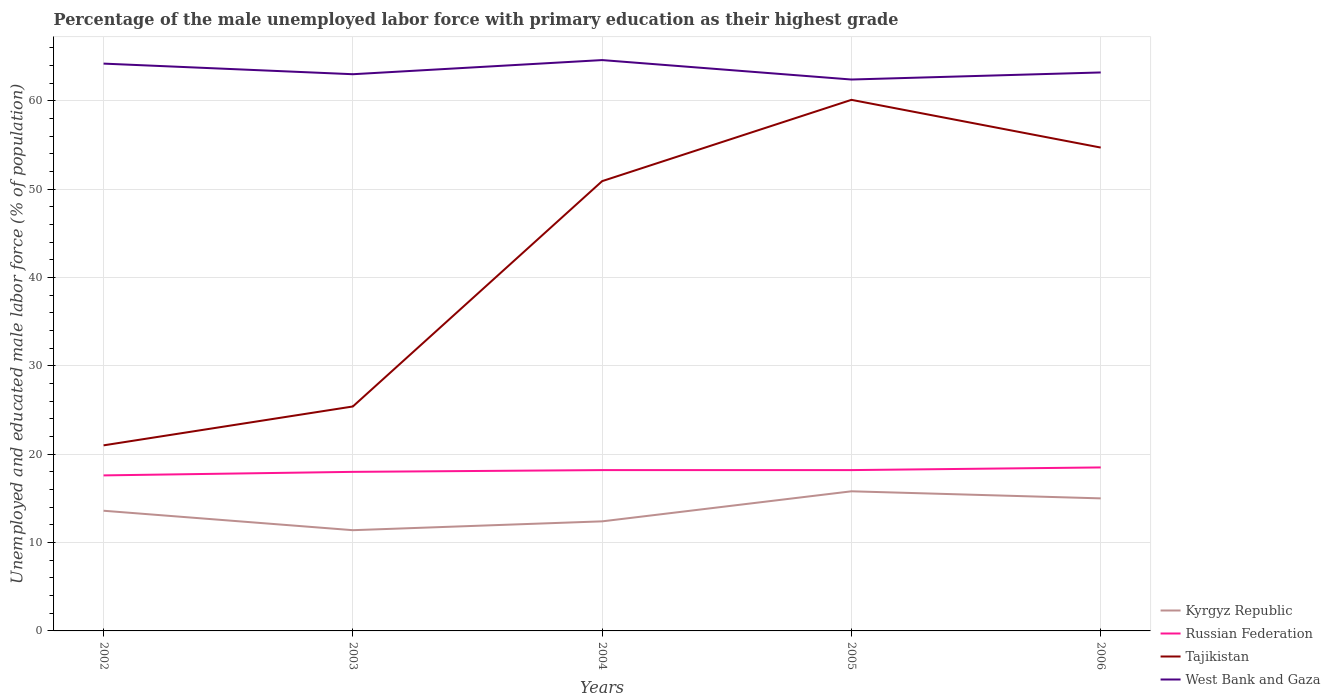How many different coloured lines are there?
Ensure brevity in your answer.  4. Across all years, what is the maximum percentage of the unemployed male labor force with primary education in Tajikistan?
Your response must be concise. 21. What is the total percentage of the unemployed male labor force with primary education in Tajikistan in the graph?
Your response must be concise. -33.7. What is the difference between the highest and the second highest percentage of the unemployed male labor force with primary education in Russian Federation?
Give a very brief answer. 0.9. What is the difference between the highest and the lowest percentage of the unemployed male labor force with primary education in Tajikistan?
Give a very brief answer. 3. Does the graph contain any zero values?
Your answer should be compact. No. How many legend labels are there?
Your answer should be very brief. 4. What is the title of the graph?
Provide a succinct answer. Percentage of the male unemployed labor force with primary education as their highest grade. Does "Venezuela" appear as one of the legend labels in the graph?
Offer a terse response. No. What is the label or title of the Y-axis?
Offer a very short reply. Unemployed and educated male labor force (% of population). What is the Unemployed and educated male labor force (% of population) of Kyrgyz Republic in 2002?
Your response must be concise. 13.6. What is the Unemployed and educated male labor force (% of population) in Russian Federation in 2002?
Ensure brevity in your answer.  17.6. What is the Unemployed and educated male labor force (% of population) in West Bank and Gaza in 2002?
Your answer should be very brief. 64.2. What is the Unemployed and educated male labor force (% of population) in Kyrgyz Republic in 2003?
Your response must be concise. 11.4. What is the Unemployed and educated male labor force (% of population) of Tajikistan in 2003?
Make the answer very short. 25.4. What is the Unemployed and educated male labor force (% of population) of West Bank and Gaza in 2003?
Your answer should be compact. 63. What is the Unemployed and educated male labor force (% of population) in Kyrgyz Republic in 2004?
Offer a terse response. 12.4. What is the Unemployed and educated male labor force (% of population) in Russian Federation in 2004?
Provide a succinct answer. 18.2. What is the Unemployed and educated male labor force (% of population) of Tajikistan in 2004?
Ensure brevity in your answer.  50.9. What is the Unemployed and educated male labor force (% of population) in West Bank and Gaza in 2004?
Make the answer very short. 64.6. What is the Unemployed and educated male labor force (% of population) of Kyrgyz Republic in 2005?
Your answer should be compact. 15.8. What is the Unemployed and educated male labor force (% of population) in Russian Federation in 2005?
Ensure brevity in your answer.  18.2. What is the Unemployed and educated male labor force (% of population) of Tajikistan in 2005?
Your response must be concise. 60.1. What is the Unemployed and educated male labor force (% of population) of West Bank and Gaza in 2005?
Your answer should be very brief. 62.4. What is the Unemployed and educated male labor force (% of population) in Russian Federation in 2006?
Provide a succinct answer. 18.5. What is the Unemployed and educated male labor force (% of population) of Tajikistan in 2006?
Make the answer very short. 54.7. What is the Unemployed and educated male labor force (% of population) in West Bank and Gaza in 2006?
Provide a short and direct response. 63.2. Across all years, what is the maximum Unemployed and educated male labor force (% of population) in Kyrgyz Republic?
Ensure brevity in your answer.  15.8. Across all years, what is the maximum Unemployed and educated male labor force (% of population) of Russian Federation?
Your answer should be very brief. 18.5. Across all years, what is the maximum Unemployed and educated male labor force (% of population) in Tajikistan?
Your answer should be compact. 60.1. Across all years, what is the maximum Unemployed and educated male labor force (% of population) of West Bank and Gaza?
Your response must be concise. 64.6. Across all years, what is the minimum Unemployed and educated male labor force (% of population) of Kyrgyz Republic?
Ensure brevity in your answer.  11.4. Across all years, what is the minimum Unemployed and educated male labor force (% of population) in Russian Federation?
Keep it short and to the point. 17.6. Across all years, what is the minimum Unemployed and educated male labor force (% of population) in West Bank and Gaza?
Make the answer very short. 62.4. What is the total Unemployed and educated male labor force (% of population) in Kyrgyz Republic in the graph?
Provide a short and direct response. 68.2. What is the total Unemployed and educated male labor force (% of population) of Russian Federation in the graph?
Your answer should be very brief. 90.5. What is the total Unemployed and educated male labor force (% of population) in Tajikistan in the graph?
Make the answer very short. 212.1. What is the total Unemployed and educated male labor force (% of population) of West Bank and Gaza in the graph?
Ensure brevity in your answer.  317.4. What is the difference between the Unemployed and educated male labor force (% of population) in Russian Federation in 2002 and that in 2003?
Make the answer very short. -0.4. What is the difference between the Unemployed and educated male labor force (% of population) in Tajikistan in 2002 and that in 2003?
Make the answer very short. -4.4. What is the difference between the Unemployed and educated male labor force (% of population) in West Bank and Gaza in 2002 and that in 2003?
Offer a very short reply. 1.2. What is the difference between the Unemployed and educated male labor force (% of population) in Kyrgyz Republic in 2002 and that in 2004?
Your answer should be very brief. 1.2. What is the difference between the Unemployed and educated male labor force (% of population) in Tajikistan in 2002 and that in 2004?
Offer a terse response. -29.9. What is the difference between the Unemployed and educated male labor force (% of population) in Kyrgyz Republic in 2002 and that in 2005?
Your response must be concise. -2.2. What is the difference between the Unemployed and educated male labor force (% of population) of Tajikistan in 2002 and that in 2005?
Ensure brevity in your answer.  -39.1. What is the difference between the Unemployed and educated male labor force (% of population) of Kyrgyz Republic in 2002 and that in 2006?
Give a very brief answer. -1.4. What is the difference between the Unemployed and educated male labor force (% of population) in Tajikistan in 2002 and that in 2006?
Ensure brevity in your answer.  -33.7. What is the difference between the Unemployed and educated male labor force (% of population) of Russian Federation in 2003 and that in 2004?
Ensure brevity in your answer.  -0.2. What is the difference between the Unemployed and educated male labor force (% of population) in Tajikistan in 2003 and that in 2004?
Keep it short and to the point. -25.5. What is the difference between the Unemployed and educated male labor force (% of population) in Tajikistan in 2003 and that in 2005?
Keep it short and to the point. -34.7. What is the difference between the Unemployed and educated male labor force (% of population) in Kyrgyz Republic in 2003 and that in 2006?
Provide a short and direct response. -3.6. What is the difference between the Unemployed and educated male labor force (% of population) in Tajikistan in 2003 and that in 2006?
Make the answer very short. -29.3. What is the difference between the Unemployed and educated male labor force (% of population) in West Bank and Gaza in 2003 and that in 2006?
Keep it short and to the point. -0.2. What is the difference between the Unemployed and educated male labor force (% of population) of Russian Federation in 2004 and that in 2005?
Ensure brevity in your answer.  0. What is the difference between the Unemployed and educated male labor force (% of population) in West Bank and Gaza in 2004 and that in 2005?
Provide a short and direct response. 2.2. What is the difference between the Unemployed and educated male labor force (% of population) in Tajikistan in 2004 and that in 2006?
Make the answer very short. -3.8. What is the difference between the Unemployed and educated male labor force (% of population) in Russian Federation in 2005 and that in 2006?
Provide a short and direct response. -0.3. What is the difference between the Unemployed and educated male labor force (% of population) in Kyrgyz Republic in 2002 and the Unemployed and educated male labor force (% of population) in West Bank and Gaza in 2003?
Your answer should be compact. -49.4. What is the difference between the Unemployed and educated male labor force (% of population) in Russian Federation in 2002 and the Unemployed and educated male labor force (% of population) in Tajikistan in 2003?
Provide a succinct answer. -7.8. What is the difference between the Unemployed and educated male labor force (% of population) of Russian Federation in 2002 and the Unemployed and educated male labor force (% of population) of West Bank and Gaza in 2003?
Give a very brief answer. -45.4. What is the difference between the Unemployed and educated male labor force (% of population) in Tajikistan in 2002 and the Unemployed and educated male labor force (% of population) in West Bank and Gaza in 2003?
Your answer should be very brief. -42. What is the difference between the Unemployed and educated male labor force (% of population) in Kyrgyz Republic in 2002 and the Unemployed and educated male labor force (% of population) in Russian Federation in 2004?
Provide a short and direct response. -4.6. What is the difference between the Unemployed and educated male labor force (% of population) in Kyrgyz Republic in 2002 and the Unemployed and educated male labor force (% of population) in Tajikistan in 2004?
Keep it short and to the point. -37.3. What is the difference between the Unemployed and educated male labor force (% of population) of Kyrgyz Republic in 2002 and the Unemployed and educated male labor force (% of population) of West Bank and Gaza in 2004?
Your answer should be compact. -51. What is the difference between the Unemployed and educated male labor force (% of population) of Russian Federation in 2002 and the Unemployed and educated male labor force (% of population) of Tajikistan in 2004?
Keep it short and to the point. -33.3. What is the difference between the Unemployed and educated male labor force (% of population) in Russian Federation in 2002 and the Unemployed and educated male labor force (% of population) in West Bank and Gaza in 2004?
Offer a terse response. -47. What is the difference between the Unemployed and educated male labor force (% of population) of Tajikistan in 2002 and the Unemployed and educated male labor force (% of population) of West Bank and Gaza in 2004?
Your response must be concise. -43.6. What is the difference between the Unemployed and educated male labor force (% of population) of Kyrgyz Republic in 2002 and the Unemployed and educated male labor force (% of population) of Russian Federation in 2005?
Your answer should be very brief. -4.6. What is the difference between the Unemployed and educated male labor force (% of population) of Kyrgyz Republic in 2002 and the Unemployed and educated male labor force (% of population) of Tajikistan in 2005?
Your answer should be very brief. -46.5. What is the difference between the Unemployed and educated male labor force (% of population) of Kyrgyz Republic in 2002 and the Unemployed and educated male labor force (% of population) of West Bank and Gaza in 2005?
Give a very brief answer. -48.8. What is the difference between the Unemployed and educated male labor force (% of population) of Russian Federation in 2002 and the Unemployed and educated male labor force (% of population) of Tajikistan in 2005?
Make the answer very short. -42.5. What is the difference between the Unemployed and educated male labor force (% of population) of Russian Federation in 2002 and the Unemployed and educated male labor force (% of population) of West Bank and Gaza in 2005?
Your answer should be very brief. -44.8. What is the difference between the Unemployed and educated male labor force (% of population) in Tajikistan in 2002 and the Unemployed and educated male labor force (% of population) in West Bank and Gaza in 2005?
Provide a short and direct response. -41.4. What is the difference between the Unemployed and educated male labor force (% of population) of Kyrgyz Republic in 2002 and the Unemployed and educated male labor force (% of population) of Tajikistan in 2006?
Your response must be concise. -41.1. What is the difference between the Unemployed and educated male labor force (% of population) of Kyrgyz Republic in 2002 and the Unemployed and educated male labor force (% of population) of West Bank and Gaza in 2006?
Offer a terse response. -49.6. What is the difference between the Unemployed and educated male labor force (% of population) in Russian Federation in 2002 and the Unemployed and educated male labor force (% of population) in Tajikistan in 2006?
Ensure brevity in your answer.  -37.1. What is the difference between the Unemployed and educated male labor force (% of population) in Russian Federation in 2002 and the Unemployed and educated male labor force (% of population) in West Bank and Gaza in 2006?
Your answer should be very brief. -45.6. What is the difference between the Unemployed and educated male labor force (% of population) in Tajikistan in 2002 and the Unemployed and educated male labor force (% of population) in West Bank and Gaza in 2006?
Ensure brevity in your answer.  -42.2. What is the difference between the Unemployed and educated male labor force (% of population) in Kyrgyz Republic in 2003 and the Unemployed and educated male labor force (% of population) in Russian Federation in 2004?
Keep it short and to the point. -6.8. What is the difference between the Unemployed and educated male labor force (% of population) in Kyrgyz Republic in 2003 and the Unemployed and educated male labor force (% of population) in Tajikistan in 2004?
Ensure brevity in your answer.  -39.5. What is the difference between the Unemployed and educated male labor force (% of population) in Kyrgyz Republic in 2003 and the Unemployed and educated male labor force (% of population) in West Bank and Gaza in 2004?
Provide a succinct answer. -53.2. What is the difference between the Unemployed and educated male labor force (% of population) in Russian Federation in 2003 and the Unemployed and educated male labor force (% of population) in Tajikistan in 2004?
Your answer should be very brief. -32.9. What is the difference between the Unemployed and educated male labor force (% of population) in Russian Federation in 2003 and the Unemployed and educated male labor force (% of population) in West Bank and Gaza in 2004?
Your answer should be very brief. -46.6. What is the difference between the Unemployed and educated male labor force (% of population) in Tajikistan in 2003 and the Unemployed and educated male labor force (% of population) in West Bank and Gaza in 2004?
Offer a very short reply. -39.2. What is the difference between the Unemployed and educated male labor force (% of population) in Kyrgyz Republic in 2003 and the Unemployed and educated male labor force (% of population) in Russian Federation in 2005?
Make the answer very short. -6.8. What is the difference between the Unemployed and educated male labor force (% of population) in Kyrgyz Republic in 2003 and the Unemployed and educated male labor force (% of population) in Tajikistan in 2005?
Ensure brevity in your answer.  -48.7. What is the difference between the Unemployed and educated male labor force (% of population) of Kyrgyz Republic in 2003 and the Unemployed and educated male labor force (% of population) of West Bank and Gaza in 2005?
Your answer should be very brief. -51. What is the difference between the Unemployed and educated male labor force (% of population) in Russian Federation in 2003 and the Unemployed and educated male labor force (% of population) in Tajikistan in 2005?
Offer a very short reply. -42.1. What is the difference between the Unemployed and educated male labor force (% of population) in Russian Federation in 2003 and the Unemployed and educated male labor force (% of population) in West Bank and Gaza in 2005?
Your response must be concise. -44.4. What is the difference between the Unemployed and educated male labor force (% of population) in Tajikistan in 2003 and the Unemployed and educated male labor force (% of population) in West Bank and Gaza in 2005?
Give a very brief answer. -37. What is the difference between the Unemployed and educated male labor force (% of population) of Kyrgyz Republic in 2003 and the Unemployed and educated male labor force (% of population) of Tajikistan in 2006?
Offer a terse response. -43.3. What is the difference between the Unemployed and educated male labor force (% of population) in Kyrgyz Republic in 2003 and the Unemployed and educated male labor force (% of population) in West Bank and Gaza in 2006?
Your response must be concise. -51.8. What is the difference between the Unemployed and educated male labor force (% of population) in Russian Federation in 2003 and the Unemployed and educated male labor force (% of population) in Tajikistan in 2006?
Ensure brevity in your answer.  -36.7. What is the difference between the Unemployed and educated male labor force (% of population) in Russian Federation in 2003 and the Unemployed and educated male labor force (% of population) in West Bank and Gaza in 2006?
Ensure brevity in your answer.  -45.2. What is the difference between the Unemployed and educated male labor force (% of population) of Tajikistan in 2003 and the Unemployed and educated male labor force (% of population) of West Bank and Gaza in 2006?
Give a very brief answer. -37.8. What is the difference between the Unemployed and educated male labor force (% of population) in Kyrgyz Republic in 2004 and the Unemployed and educated male labor force (% of population) in Tajikistan in 2005?
Your response must be concise. -47.7. What is the difference between the Unemployed and educated male labor force (% of population) of Kyrgyz Republic in 2004 and the Unemployed and educated male labor force (% of population) of West Bank and Gaza in 2005?
Your response must be concise. -50. What is the difference between the Unemployed and educated male labor force (% of population) of Russian Federation in 2004 and the Unemployed and educated male labor force (% of population) of Tajikistan in 2005?
Give a very brief answer. -41.9. What is the difference between the Unemployed and educated male labor force (% of population) of Russian Federation in 2004 and the Unemployed and educated male labor force (% of population) of West Bank and Gaza in 2005?
Your response must be concise. -44.2. What is the difference between the Unemployed and educated male labor force (% of population) of Kyrgyz Republic in 2004 and the Unemployed and educated male labor force (% of population) of Russian Federation in 2006?
Provide a short and direct response. -6.1. What is the difference between the Unemployed and educated male labor force (% of population) in Kyrgyz Republic in 2004 and the Unemployed and educated male labor force (% of population) in Tajikistan in 2006?
Offer a terse response. -42.3. What is the difference between the Unemployed and educated male labor force (% of population) of Kyrgyz Republic in 2004 and the Unemployed and educated male labor force (% of population) of West Bank and Gaza in 2006?
Ensure brevity in your answer.  -50.8. What is the difference between the Unemployed and educated male labor force (% of population) in Russian Federation in 2004 and the Unemployed and educated male labor force (% of population) in Tajikistan in 2006?
Your answer should be compact. -36.5. What is the difference between the Unemployed and educated male labor force (% of population) of Russian Federation in 2004 and the Unemployed and educated male labor force (% of population) of West Bank and Gaza in 2006?
Your answer should be very brief. -45. What is the difference between the Unemployed and educated male labor force (% of population) of Kyrgyz Republic in 2005 and the Unemployed and educated male labor force (% of population) of Tajikistan in 2006?
Your response must be concise. -38.9. What is the difference between the Unemployed and educated male labor force (% of population) of Kyrgyz Republic in 2005 and the Unemployed and educated male labor force (% of population) of West Bank and Gaza in 2006?
Your answer should be very brief. -47.4. What is the difference between the Unemployed and educated male labor force (% of population) of Russian Federation in 2005 and the Unemployed and educated male labor force (% of population) of Tajikistan in 2006?
Offer a very short reply. -36.5. What is the difference between the Unemployed and educated male labor force (% of population) in Russian Federation in 2005 and the Unemployed and educated male labor force (% of population) in West Bank and Gaza in 2006?
Provide a short and direct response. -45. What is the average Unemployed and educated male labor force (% of population) of Kyrgyz Republic per year?
Your response must be concise. 13.64. What is the average Unemployed and educated male labor force (% of population) in Tajikistan per year?
Your response must be concise. 42.42. What is the average Unemployed and educated male labor force (% of population) of West Bank and Gaza per year?
Give a very brief answer. 63.48. In the year 2002, what is the difference between the Unemployed and educated male labor force (% of population) of Kyrgyz Republic and Unemployed and educated male labor force (% of population) of Russian Federation?
Your answer should be compact. -4. In the year 2002, what is the difference between the Unemployed and educated male labor force (% of population) in Kyrgyz Republic and Unemployed and educated male labor force (% of population) in West Bank and Gaza?
Give a very brief answer. -50.6. In the year 2002, what is the difference between the Unemployed and educated male labor force (% of population) of Russian Federation and Unemployed and educated male labor force (% of population) of West Bank and Gaza?
Ensure brevity in your answer.  -46.6. In the year 2002, what is the difference between the Unemployed and educated male labor force (% of population) of Tajikistan and Unemployed and educated male labor force (% of population) of West Bank and Gaza?
Your answer should be very brief. -43.2. In the year 2003, what is the difference between the Unemployed and educated male labor force (% of population) in Kyrgyz Republic and Unemployed and educated male labor force (% of population) in Russian Federation?
Provide a short and direct response. -6.6. In the year 2003, what is the difference between the Unemployed and educated male labor force (% of population) in Kyrgyz Republic and Unemployed and educated male labor force (% of population) in West Bank and Gaza?
Provide a succinct answer. -51.6. In the year 2003, what is the difference between the Unemployed and educated male labor force (% of population) of Russian Federation and Unemployed and educated male labor force (% of population) of West Bank and Gaza?
Provide a succinct answer. -45. In the year 2003, what is the difference between the Unemployed and educated male labor force (% of population) of Tajikistan and Unemployed and educated male labor force (% of population) of West Bank and Gaza?
Provide a succinct answer. -37.6. In the year 2004, what is the difference between the Unemployed and educated male labor force (% of population) of Kyrgyz Republic and Unemployed and educated male labor force (% of population) of Tajikistan?
Provide a short and direct response. -38.5. In the year 2004, what is the difference between the Unemployed and educated male labor force (% of population) of Kyrgyz Republic and Unemployed and educated male labor force (% of population) of West Bank and Gaza?
Provide a short and direct response. -52.2. In the year 2004, what is the difference between the Unemployed and educated male labor force (% of population) in Russian Federation and Unemployed and educated male labor force (% of population) in Tajikistan?
Your response must be concise. -32.7. In the year 2004, what is the difference between the Unemployed and educated male labor force (% of population) in Russian Federation and Unemployed and educated male labor force (% of population) in West Bank and Gaza?
Provide a short and direct response. -46.4. In the year 2004, what is the difference between the Unemployed and educated male labor force (% of population) of Tajikistan and Unemployed and educated male labor force (% of population) of West Bank and Gaza?
Offer a very short reply. -13.7. In the year 2005, what is the difference between the Unemployed and educated male labor force (% of population) in Kyrgyz Republic and Unemployed and educated male labor force (% of population) in Russian Federation?
Provide a succinct answer. -2.4. In the year 2005, what is the difference between the Unemployed and educated male labor force (% of population) in Kyrgyz Republic and Unemployed and educated male labor force (% of population) in Tajikistan?
Keep it short and to the point. -44.3. In the year 2005, what is the difference between the Unemployed and educated male labor force (% of population) in Kyrgyz Republic and Unemployed and educated male labor force (% of population) in West Bank and Gaza?
Provide a short and direct response. -46.6. In the year 2005, what is the difference between the Unemployed and educated male labor force (% of population) of Russian Federation and Unemployed and educated male labor force (% of population) of Tajikistan?
Offer a very short reply. -41.9. In the year 2005, what is the difference between the Unemployed and educated male labor force (% of population) of Russian Federation and Unemployed and educated male labor force (% of population) of West Bank and Gaza?
Make the answer very short. -44.2. In the year 2005, what is the difference between the Unemployed and educated male labor force (% of population) in Tajikistan and Unemployed and educated male labor force (% of population) in West Bank and Gaza?
Make the answer very short. -2.3. In the year 2006, what is the difference between the Unemployed and educated male labor force (% of population) in Kyrgyz Republic and Unemployed and educated male labor force (% of population) in Tajikistan?
Your answer should be compact. -39.7. In the year 2006, what is the difference between the Unemployed and educated male labor force (% of population) of Kyrgyz Republic and Unemployed and educated male labor force (% of population) of West Bank and Gaza?
Your answer should be very brief. -48.2. In the year 2006, what is the difference between the Unemployed and educated male labor force (% of population) in Russian Federation and Unemployed and educated male labor force (% of population) in Tajikistan?
Your answer should be very brief. -36.2. In the year 2006, what is the difference between the Unemployed and educated male labor force (% of population) of Russian Federation and Unemployed and educated male labor force (% of population) of West Bank and Gaza?
Provide a succinct answer. -44.7. In the year 2006, what is the difference between the Unemployed and educated male labor force (% of population) of Tajikistan and Unemployed and educated male labor force (% of population) of West Bank and Gaza?
Your answer should be very brief. -8.5. What is the ratio of the Unemployed and educated male labor force (% of population) in Kyrgyz Republic in 2002 to that in 2003?
Keep it short and to the point. 1.19. What is the ratio of the Unemployed and educated male labor force (% of population) in Russian Federation in 2002 to that in 2003?
Provide a short and direct response. 0.98. What is the ratio of the Unemployed and educated male labor force (% of population) in Tajikistan in 2002 to that in 2003?
Give a very brief answer. 0.83. What is the ratio of the Unemployed and educated male labor force (% of population) in West Bank and Gaza in 2002 to that in 2003?
Offer a very short reply. 1.02. What is the ratio of the Unemployed and educated male labor force (% of population) in Kyrgyz Republic in 2002 to that in 2004?
Give a very brief answer. 1.1. What is the ratio of the Unemployed and educated male labor force (% of population) of Russian Federation in 2002 to that in 2004?
Your answer should be compact. 0.97. What is the ratio of the Unemployed and educated male labor force (% of population) in Tajikistan in 2002 to that in 2004?
Offer a very short reply. 0.41. What is the ratio of the Unemployed and educated male labor force (% of population) in West Bank and Gaza in 2002 to that in 2004?
Your answer should be compact. 0.99. What is the ratio of the Unemployed and educated male labor force (% of population) in Kyrgyz Republic in 2002 to that in 2005?
Provide a short and direct response. 0.86. What is the ratio of the Unemployed and educated male labor force (% of population) of Tajikistan in 2002 to that in 2005?
Offer a very short reply. 0.35. What is the ratio of the Unemployed and educated male labor force (% of population) of West Bank and Gaza in 2002 to that in 2005?
Make the answer very short. 1.03. What is the ratio of the Unemployed and educated male labor force (% of population) in Kyrgyz Republic in 2002 to that in 2006?
Make the answer very short. 0.91. What is the ratio of the Unemployed and educated male labor force (% of population) of Russian Federation in 2002 to that in 2006?
Keep it short and to the point. 0.95. What is the ratio of the Unemployed and educated male labor force (% of population) in Tajikistan in 2002 to that in 2006?
Provide a short and direct response. 0.38. What is the ratio of the Unemployed and educated male labor force (% of population) in West Bank and Gaza in 2002 to that in 2006?
Your response must be concise. 1.02. What is the ratio of the Unemployed and educated male labor force (% of population) of Kyrgyz Republic in 2003 to that in 2004?
Your response must be concise. 0.92. What is the ratio of the Unemployed and educated male labor force (% of population) in Tajikistan in 2003 to that in 2004?
Your response must be concise. 0.5. What is the ratio of the Unemployed and educated male labor force (% of population) of West Bank and Gaza in 2003 to that in 2004?
Keep it short and to the point. 0.98. What is the ratio of the Unemployed and educated male labor force (% of population) in Kyrgyz Republic in 2003 to that in 2005?
Keep it short and to the point. 0.72. What is the ratio of the Unemployed and educated male labor force (% of population) in Russian Federation in 2003 to that in 2005?
Ensure brevity in your answer.  0.99. What is the ratio of the Unemployed and educated male labor force (% of population) in Tajikistan in 2003 to that in 2005?
Make the answer very short. 0.42. What is the ratio of the Unemployed and educated male labor force (% of population) in West Bank and Gaza in 2003 to that in 2005?
Your answer should be very brief. 1.01. What is the ratio of the Unemployed and educated male labor force (% of population) in Kyrgyz Republic in 2003 to that in 2006?
Make the answer very short. 0.76. What is the ratio of the Unemployed and educated male labor force (% of population) of Tajikistan in 2003 to that in 2006?
Offer a very short reply. 0.46. What is the ratio of the Unemployed and educated male labor force (% of population) of Kyrgyz Republic in 2004 to that in 2005?
Make the answer very short. 0.78. What is the ratio of the Unemployed and educated male labor force (% of population) of Tajikistan in 2004 to that in 2005?
Your answer should be very brief. 0.85. What is the ratio of the Unemployed and educated male labor force (% of population) in West Bank and Gaza in 2004 to that in 2005?
Give a very brief answer. 1.04. What is the ratio of the Unemployed and educated male labor force (% of population) in Kyrgyz Republic in 2004 to that in 2006?
Your answer should be very brief. 0.83. What is the ratio of the Unemployed and educated male labor force (% of population) of Russian Federation in 2004 to that in 2006?
Your answer should be very brief. 0.98. What is the ratio of the Unemployed and educated male labor force (% of population) of Tajikistan in 2004 to that in 2006?
Your answer should be compact. 0.93. What is the ratio of the Unemployed and educated male labor force (% of population) in West Bank and Gaza in 2004 to that in 2006?
Provide a short and direct response. 1.02. What is the ratio of the Unemployed and educated male labor force (% of population) of Kyrgyz Republic in 2005 to that in 2006?
Provide a succinct answer. 1.05. What is the ratio of the Unemployed and educated male labor force (% of population) of Russian Federation in 2005 to that in 2006?
Give a very brief answer. 0.98. What is the ratio of the Unemployed and educated male labor force (% of population) of Tajikistan in 2005 to that in 2006?
Your response must be concise. 1.1. What is the ratio of the Unemployed and educated male labor force (% of population) in West Bank and Gaza in 2005 to that in 2006?
Your answer should be compact. 0.99. What is the difference between the highest and the second highest Unemployed and educated male labor force (% of population) of Kyrgyz Republic?
Give a very brief answer. 0.8. What is the difference between the highest and the second highest Unemployed and educated male labor force (% of population) in Russian Federation?
Give a very brief answer. 0.3. What is the difference between the highest and the lowest Unemployed and educated male labor force (% of population) in Russian Federation?
Offer a very short reply. 0.9. What is the difference between the highest and the lowest Unemployed and educated male labor force (% of population) of Tajikistan?
Your answer should be very brief. 39.1. What is the difference between the highest and the lowest Unemployed and educated male labor force (% of population) of West Bank and Gaza?
Offer a very short reply. 2.2. 